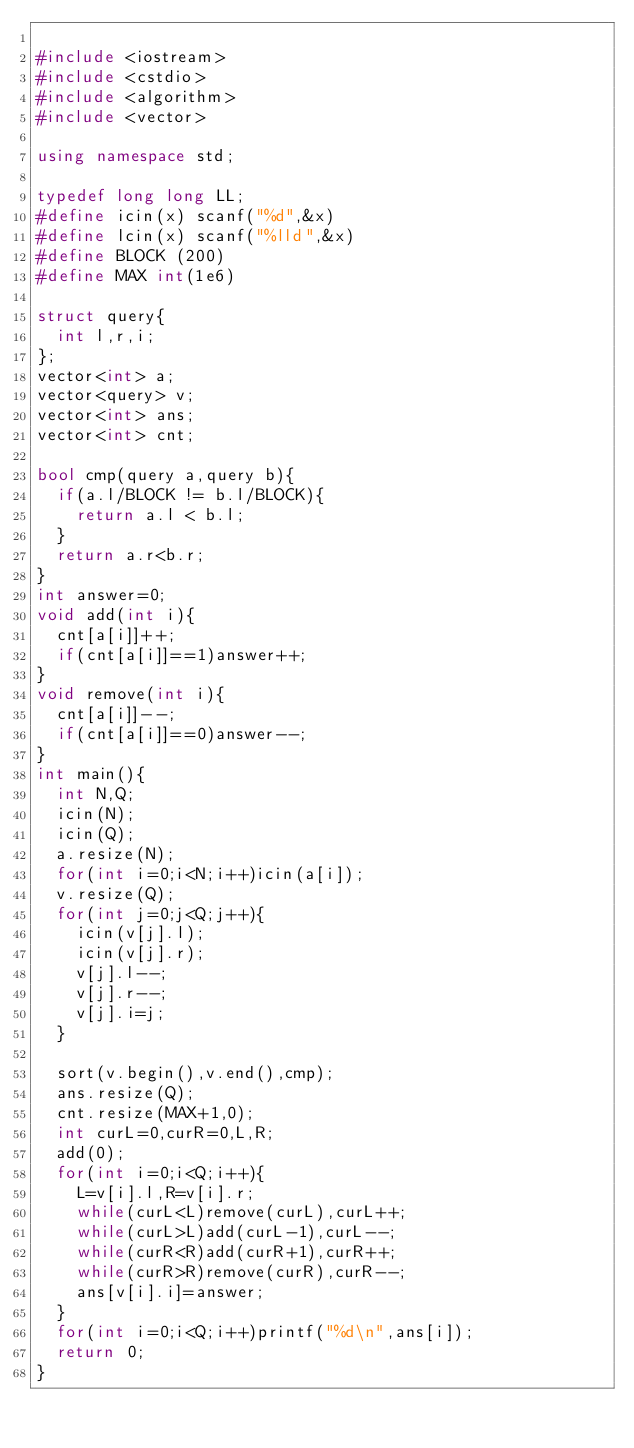<code> <loc_0><loc_0><loc_500><loc_500><_C++_>  
#include <iostream>
#include <cstdio>
#include <algorithm>
#include <vector>

using namespace std;

typedef long long LL;
#define icin(x) scanf("%d",&x)
#define lcin(x) scanf("%lld",&x)
#define BLOCK (200)
#define MAX int(1e6)

struct query{
	int l,r,i;
};
vector<int> a;
vector<query> v;
vector<int> ans;
vector<int> cnt;

bool cmp(query a,query b){
	if(a.l/BLOCK != b.l/BLOCK){
		return a.l < b.l;
	}
	return a.r<b.r;
}
int answer=0;
void add(int i){
	cnt[a[i]]++;
	if(cnt[a[i]]==1)answer++;
}
void remove(int i){
	cnt[a[i]]--;
	if(cnt[a[i]]==0)answer--;
}
int main(){
	int N,Q;
	icin(N);
	icin(Q);
	a.resize(N);
	for(int i=0;i<N;i++)icin(a[i]);
	v.resize(Q);
	for(int j=0;j<Q;j++){
		icin(v[j].l);
		icin(v[j].r);
		v[j].l--;
		v[j].r--;
		v[j].i=j;
	}

	sort(v.begin(),v.end(),cmp);
	ans.resize(Q);
	cnt.resize(MAX+1,0);
	int curL=0,curR=0,L,R;
	add(0);
	for(int i=0;i<Q;i++){
		L=v[i].l,R=v[i].r;
		while(curL<L)remove(curL),curL++;
		while(curL>L)add(curL-1),curL--;
		while(curR<R)add(curR+1),curR++;
		while(curR>R)remove(curR),curR--;
		ans[v[i].i]=answer;
	}
	for(int i=0;i<Q;i++)printf("%d\n",ans[i]);
	return 0;
}</code> 